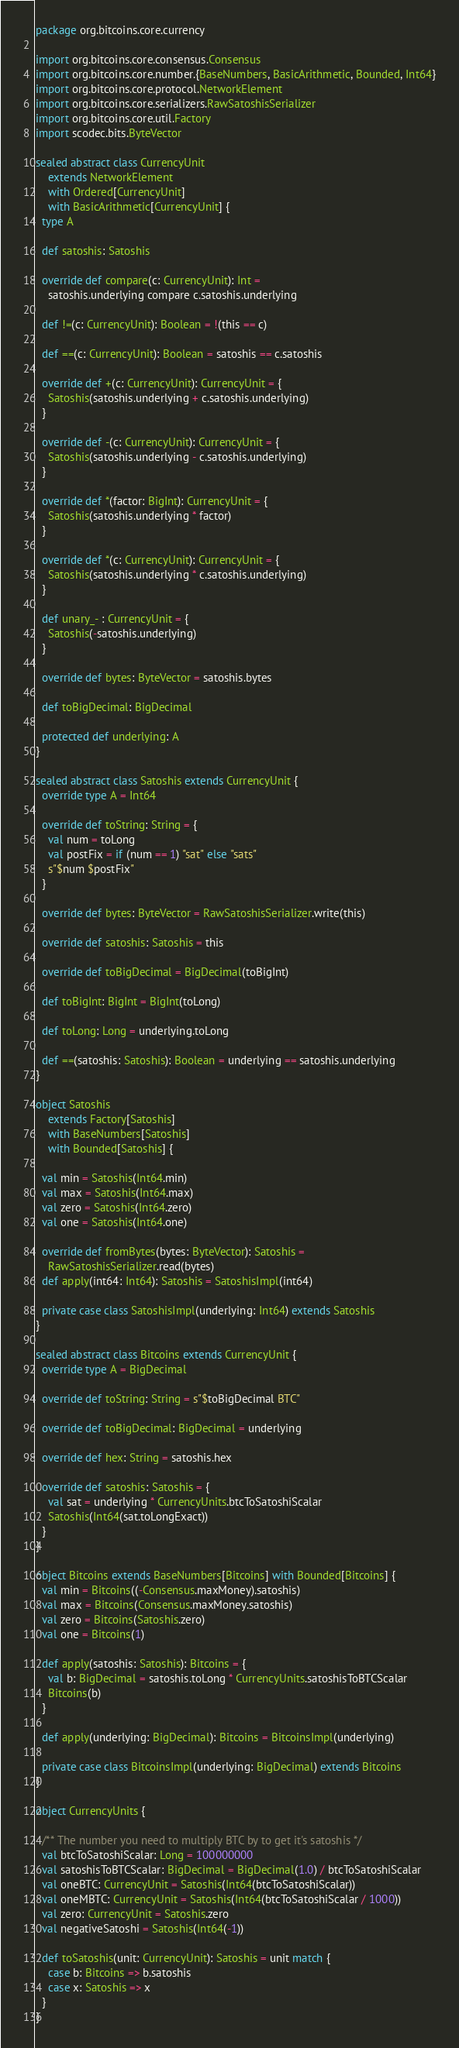<code> <loc_0><loc_0><loc_500><loc_500><_Scala_>package org.bitcoins.core.currency

import org.bitcoins.core.consensus.Consensus
import org.bitcoins.core.number.{BaseNumbers, BasicArithmetic, Bounded, Int64}
import org.bitcoins.core.protocol.NetworkElement
import org.bitcoins.core.serializers.RawSatoshisSerializer
import org.bitcoins.core.util.Factory
import scodec.bits.ByteVector

sealed abstract class CurrencyUnit
    extends NetworkElement
    with Ordered[CurrencyUnit]
    with BasicArithmetic[CurrencyUnit] {
  type A

  def satoshis: Satoshis

  override def compare(c: CurrencyUnit): Int =
    satoshis.underlying compare c.satoshis.underlying

  def !=(c: CurrencyUnit): Boolean = !(this == c)

  def ==(c: CurrencyUnit): Boolean = satoshis == c.satoshis

  override def +(c: CurrencyUnit): CurrencyUnit = {
    Satoshis(satoshis.underlying + c.satoshis.underlying)
  }

  override def -(c: CurrencyUnit): CurrencyUnit = {
    Satoshis(satoshis.underlying - c.satoshis.underlying)
  }

  override def *(factor: BigInt): CurrencyUnit = {
    Satoshis(satoshis.underlying * factor)
  }

  override def *(c: CurrencyUnit): CurrencyUnit = {
    Satoshis(satoshis.underlying * c.satoshis.underlying)
  }

  def unary_- : CurrencyUnit = {
    Satoshis(-satoshis.underlying)
  }

  override def bytes: ByteVector = satoshis.bytes

  def toBigDecimal: BigDecimal

  protected def underlying: A
}

sealed abstract class Satoshis extends CurrencyUnit {
  override type A = Int64

  override def toString: String = {
    val num = toLong
    val postFix = if (num == 1) "sat" else "sats"
    s"$num $postFix"
  }

  override def bytes: ByteVector = RawSatoshisSerializer.write(this)

  override def satoshis: Satoshis = this

  override def toBigDecimal = BigDecimal(toBigInt)

  def toBigInt: BigInt = BigInt(toLong)

  def toLong: Long = underlying.toLong

  def ==(satoshis: Satoshis): Boolean = underlying == satoshis.underlying
}

object Satoshis
    extends Factory[Satoshis]
    with BaseNumbers[Satoshis]
    with Bounded[Satoshis] {

  val min = Satoshis(Int64.min)
  val max = Satoshis(Int64.max)
  val zero = Satoshis(Int64.zero)
  val one = Satoshis(Int64.one)

  override def fromBytes(bytes: ByteVector): Satoshis =
    RawSatoshisSerializer.read(bytes)
  def apply(int64: Int64): Satoshis = SatoshisImpl(int64)

  private case class SatoshisImpl(underlying: Int64) extends Satoshis
}

sealed abstract class Bitcoins extends CurrencyUnit {
  override type A = BigDecimal

  override def toString: String = s"$toBigDecimal BTC"

  override def toBigDecimal: BigDecimal = underlying

  override def hex: String = satoshis.hex

  override def satoshis: Satoshis = {
    val sat = underlying * CurrencyUnits.btcToSatoshiScalar
    Satoshis(Int64(sat.toLongExact))
  }
}

object Bitcoins extends BaseNumbers[Bitcoins] with Bounded[Bitcoins] {
  val min = Bitcoins((-Consensus.maxMoney).satoshis)
  val max = Bitcoins(Consensus.maxMoney.satoshis)
  val zero = Bitcoins(Satoshis.zero)
  val one = Bitcoins(1)

  def apply(satoshis: Satoshis): Bitcoins = {
    val b: BigDecimal = satoshis.toLong * CurrencyUnits.satoshisToBTCScalar
    Bitcoins(b)
  }

  def apply(underlying: BigDecimal): Bitcoins = BitcoinsImpl(underlying)

  private case class BitcoinsImpl(underlying: BigDecimal) extends Bitcoins
}

object CurrencyUnits {

  /** The number you need to multiply BTC by to get it's satoshis */
  val btcToSatoshiScalar: Long = 100000000
  val satoshisToBTCScalar: BigDecimal = BigDecimal(1.0) / btcToSatoshiScalar
  val oneBTC: CurrencyUnit = Satoshis(Int64(btcToSatoshiScalar))
  val oneMBTC: CurrencyUnit = Satoshis(Int64(btcToSatoshiScalar / 1000))
  val zero: CurrencyUnit = Satoshis.zero
  val negativeSatoshi = Satoshis(Int64(-1))

  def toSatoshis(unit: CurrencyUnit): Satoshis = unit match {
    case b: Bitcoins => b.satoshis
    case x: Satoshis => x
  }
}
</code> 